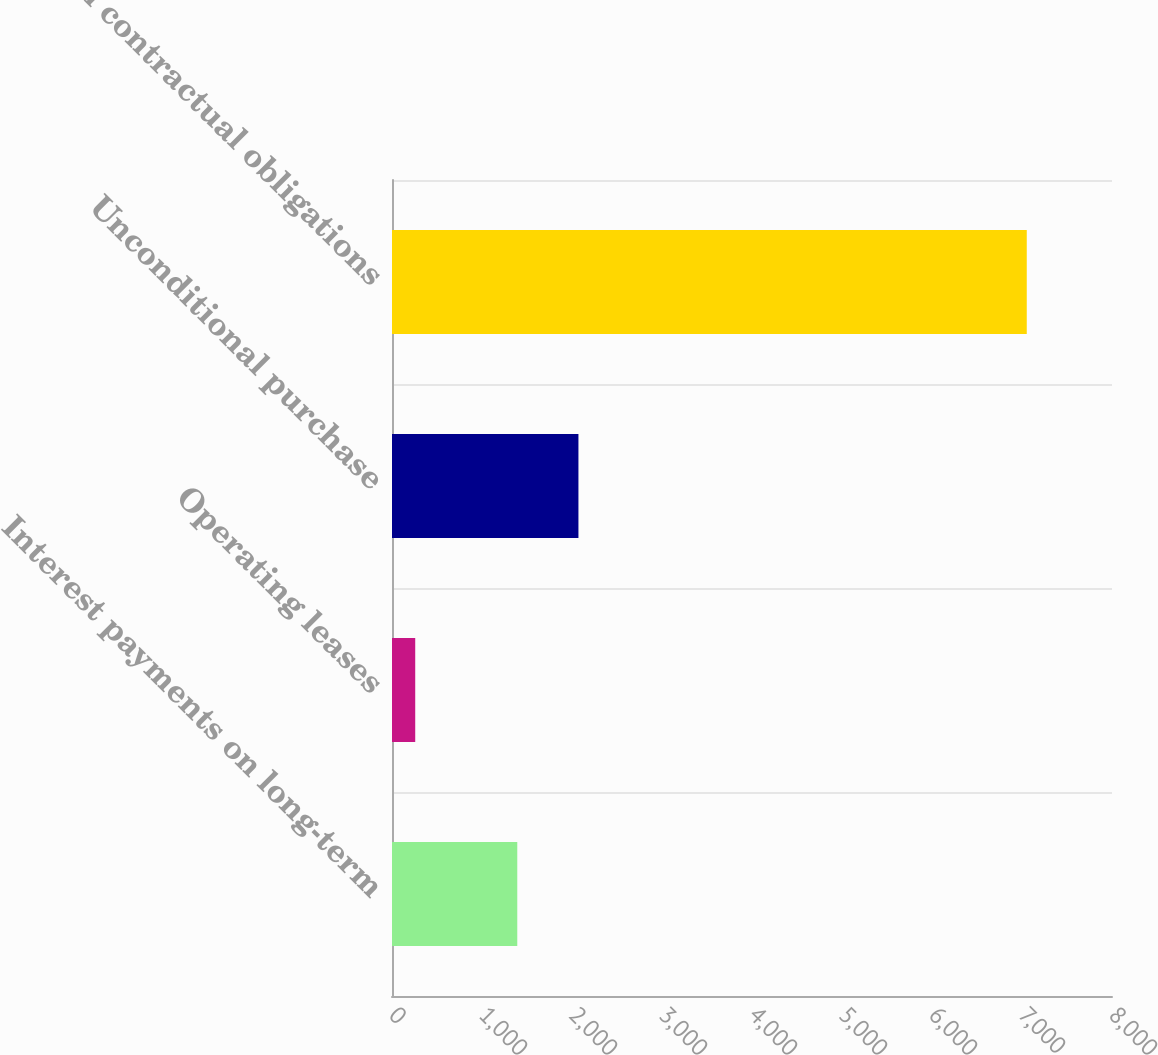Convert chart. <chart><loc_0><loc_0><loc_500><loc_500><bar_chart><fcel>Interest payments on long-term<fcel>Operating leases<fcel>Unconditional purchase<fcel>Total contractual obligations<nl><fcel>1392<fcel>258<fcel>2071.5<fcel>7053<nl></chart> 